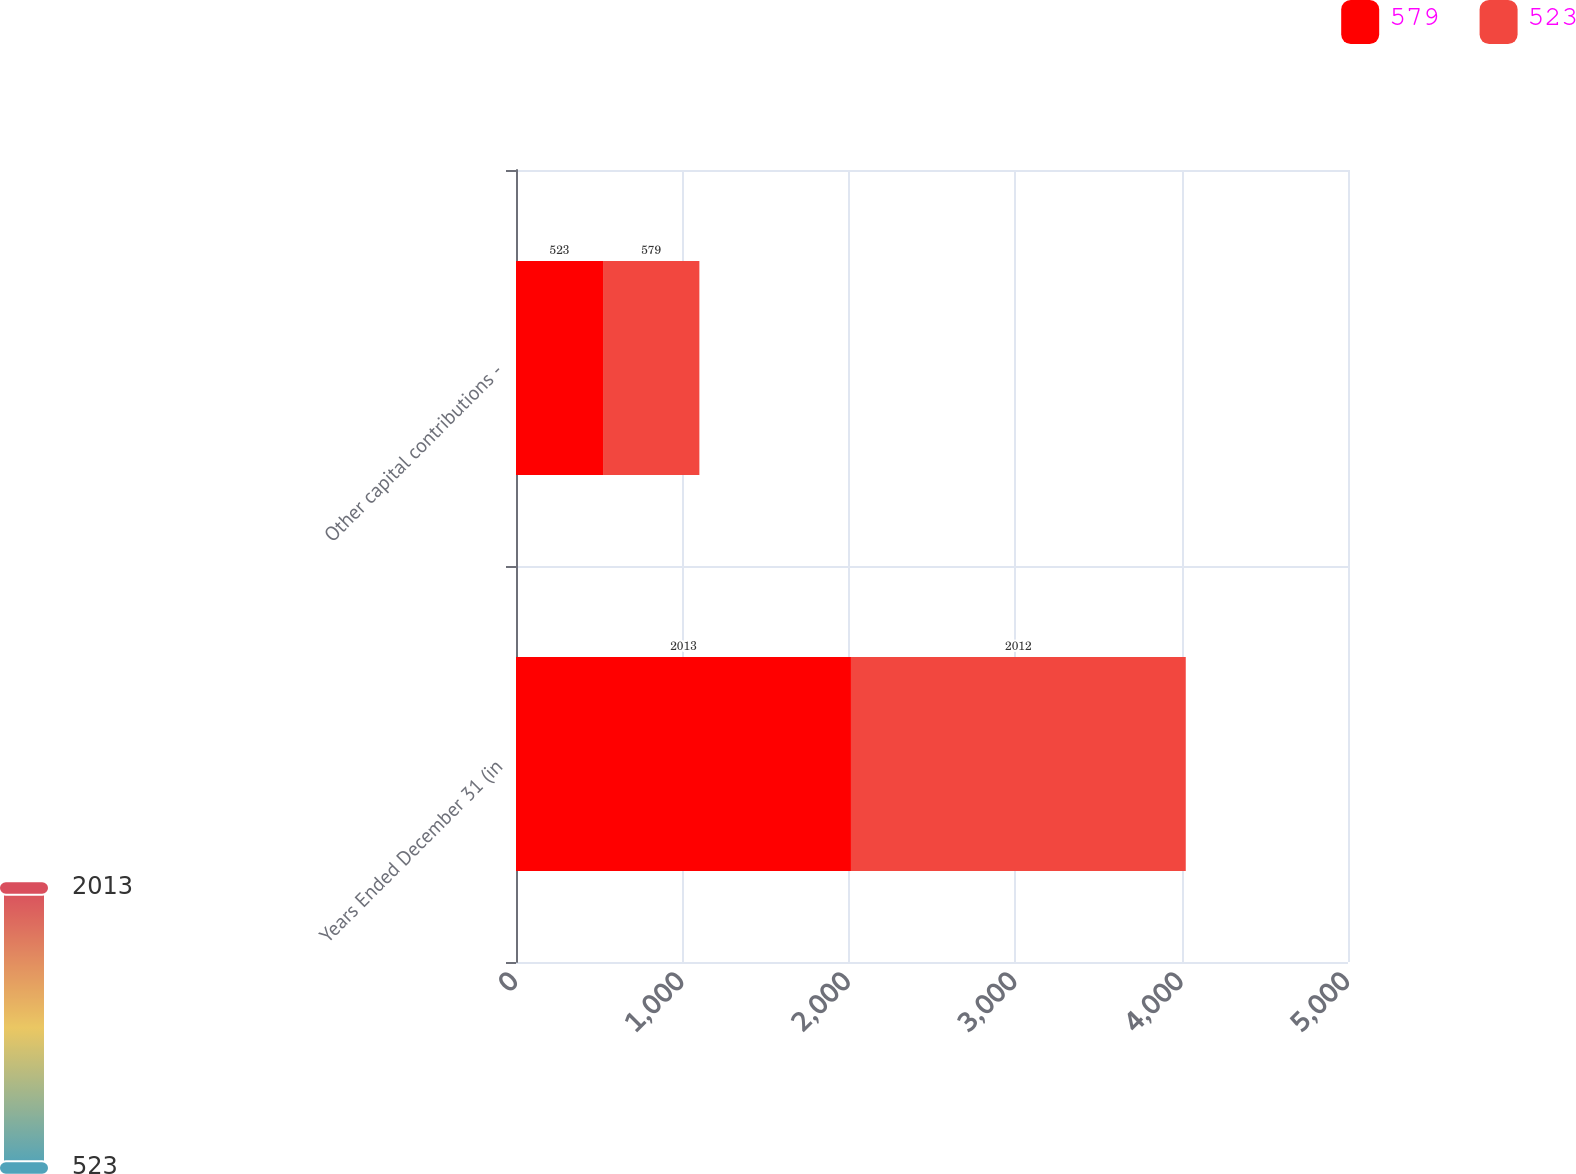Convert chart. <chart><loc_0><loc_0><loc_500><loc_500><stacked_bar_chart><ecel><fcel>Years Ended December 31 (in<fcel>Other capital contributions -<nl><fcel>579<fcel>2013<fcel>523<nl><fcel>523<fcel>2012<fcel>579<nl></chart> 